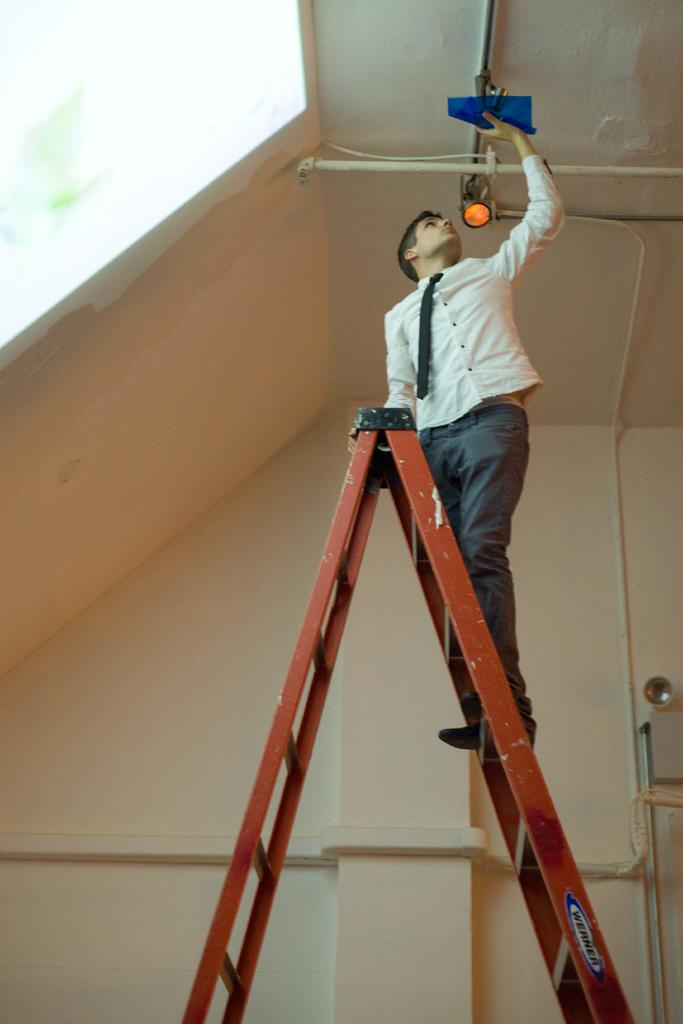What object is present in the image that allows someone to reach a higher position? There is a ladder in the image. Who is using the ladder in the image? A person is standing on the ladder. What is the person doing while on the ladder? The person is fixing something to the roof. What can be seen in the background of the image? There is a wall in the background of the image. What type of plant is providing pleasure to the person on the ladder? There is no plant present in the image, and no indication that the person is experiencing pleasure. 